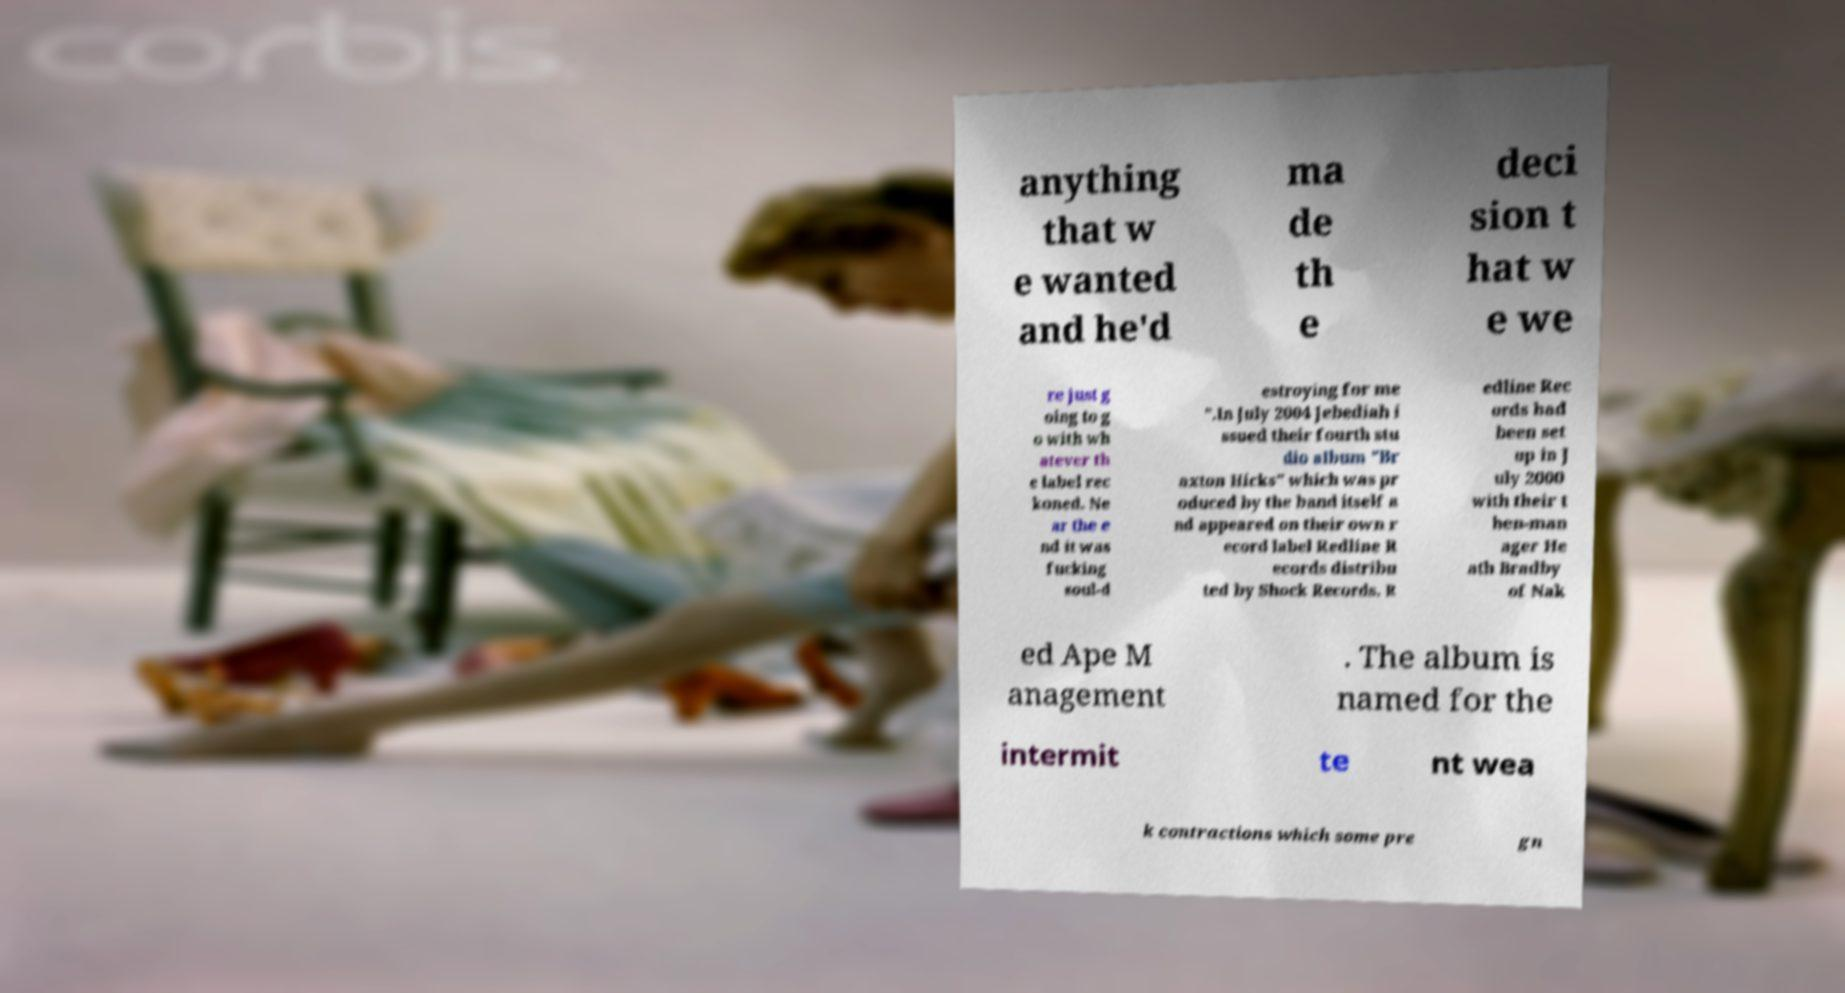Please read and relay the text visible in this image. What does it say? anything that w e wanted and he'd ma de th e deci sion t hat w e we re just g oing to g o with wh atever th e label rec koned. Ne ar the e nd it was fucking soul-d estroying for me ".In July 2004 Jebediah i ssued their fourth stu dio album "Br axton Hicks" which was pr oduced by the band itself a nd appeared on their own r ecord label Redline R ecords distribu ted by Shock Records. R edline Rec ords had been set up in J uly 2000 with their t hen-man ager He ath Bradby of Nak ed Ape M anagement . The album is named for the intermit te nt wea k contractions which some pre gn 